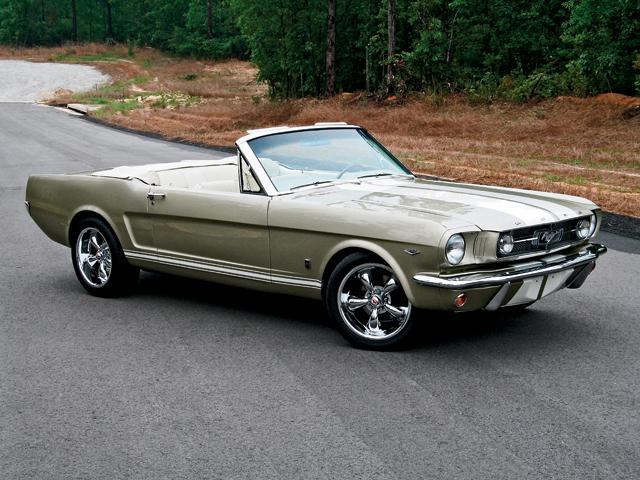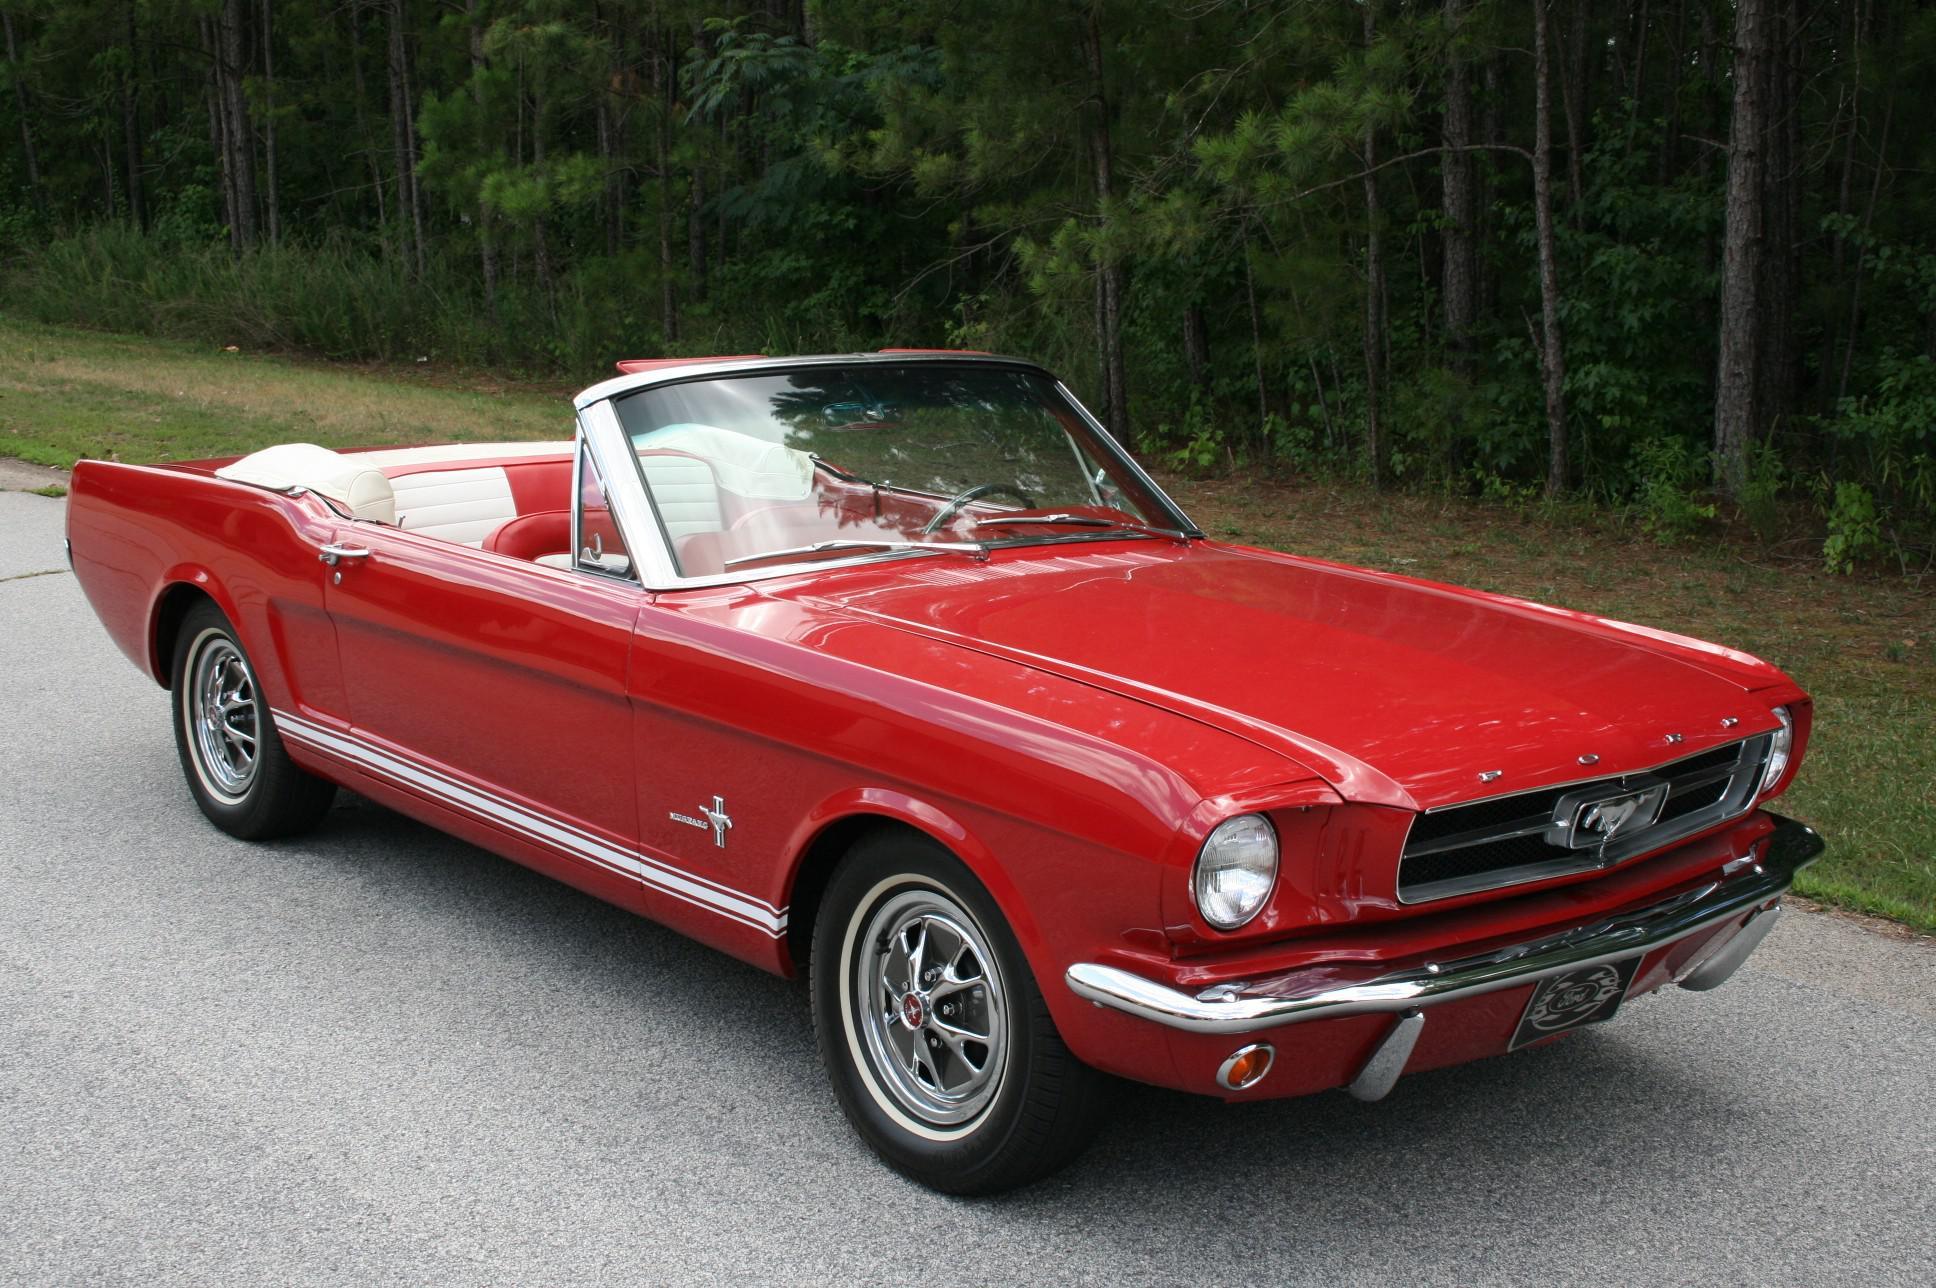The first image is the image on the left, the second image is the image on the right. Evaluate the accuracy of this statement regarding the images: "There is a car whose main body color is red.". Is it true? Answer yes or no. Yes. The first image is the image on the left, the second image is the image on the right. Evaluate the accuracy of this statement regarding the images: "One of the images has a red Ford Mustang convertible.". Is it true? Answer yes or no. Yes. 